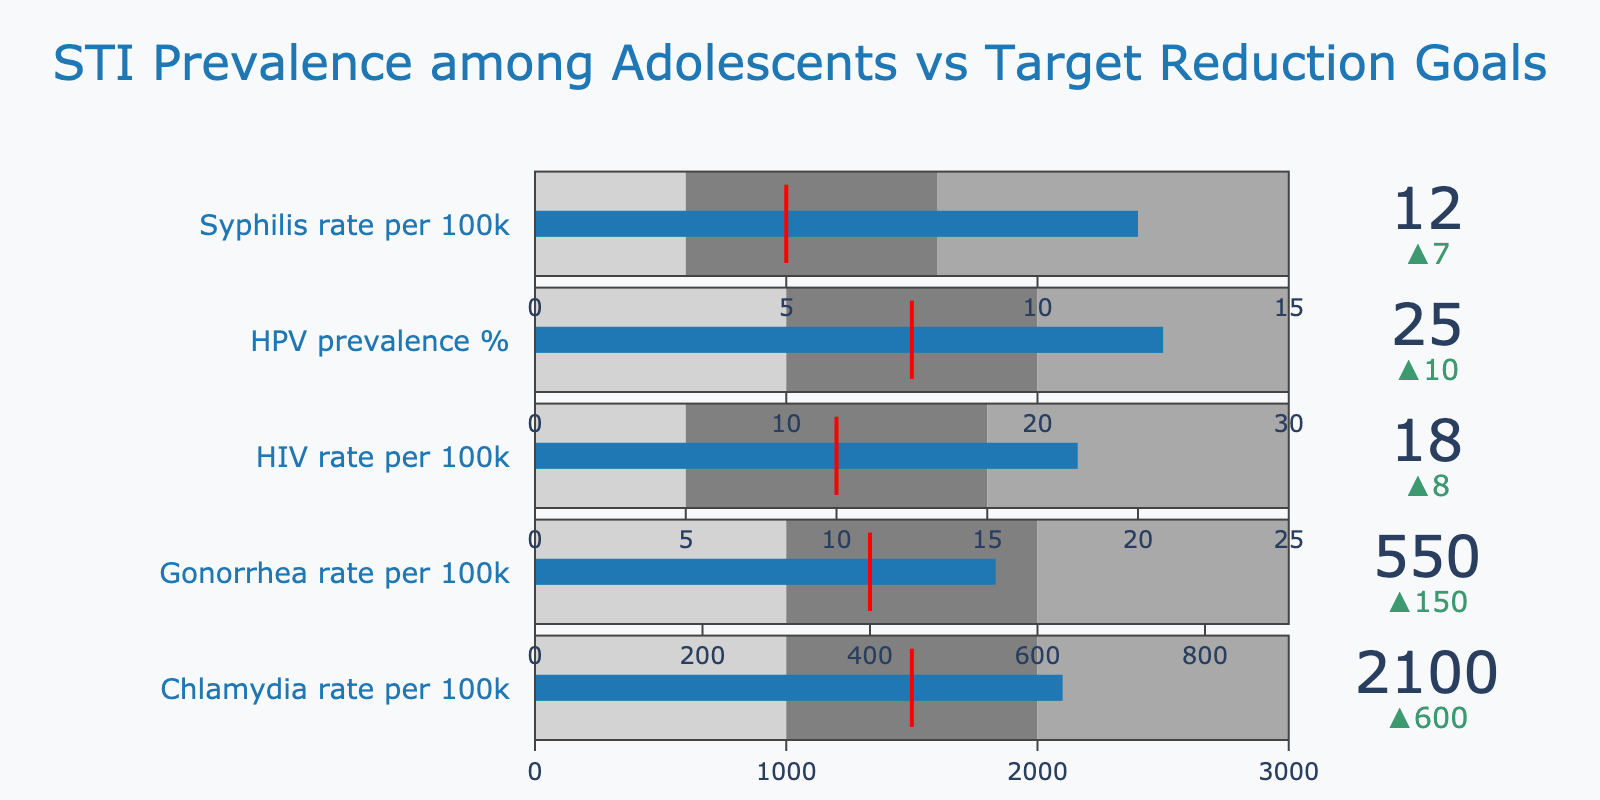What's the title of the chart? The title of the chart is displayed at the top in large font. It reads "STI Prevalence among Adolescents vs Target Reduction Goals".
Answer: STI Prevalence among Adolescents vs Target Reduction Goals Which STI has the highest actual rate per 100,000? By looking at the values indicated in the bullet chart, the bar representing "Chlamydia rate per 100k" has an actual value of 2100, which is the highest among all the STIs shown.
Answer: Chlamydia How much higher is the Syphilis rate per 100,000 than its target? The actual rate for Syphilis is 12 per 100k, and the target is 5 per 100k. The difference is calculated as 12 - 5.
Answer: 7 Which STI is closest to its target rate? We identify the actual value and target value for each STI and compare the differences. The smallest difference is for Gonorrhea (actual 550, target 400), which is a difference of 150.
Answer: Gonorrhea What is the target reduction goal for HPV prevalence in percentage? For "HPV prevalence %," the target is shown at the middle of the bullet gauge. It's listed as 15%.
Answer: 15% Are there any STIs where the actual value is less than the range2 threshold? By comparing the actual values with the second range limit, we see that for HIV and Syphilis, the actual values (18 and 12 respectively) are lower than the range2 thresholds (15 and 8 respectively).
Answer: Yes, HIV and Syphilis Which STI has the smallest range1 threshold? By observing the bullet charts' range1 values for each STI, we find that Syphilis has the smallest range1 threshold with a value of 3.
Answer: Syphilis What is the actual rate of Gonorrhea per 100,000? The actual value for "Gonorrhea rate per 100k" is indicated directly on the bullet chart and it is 550 per 100k.
Answer: 550 Is the Chlamydia rate per 100,000 above the dark gray (range3) threshold? The actual value for Chlamydia is 2100, while the range3 threshold (upper limit) is 3000. Since 2100 is less than 3000, it is not above the dark gray threshold.
Answer: No How far is the actual HIV rate above its target? The actual rate for HIV is 18 per 100k while the target is 10 per 100k. The difference is calculated as 18 - 10.
Answer: 8 